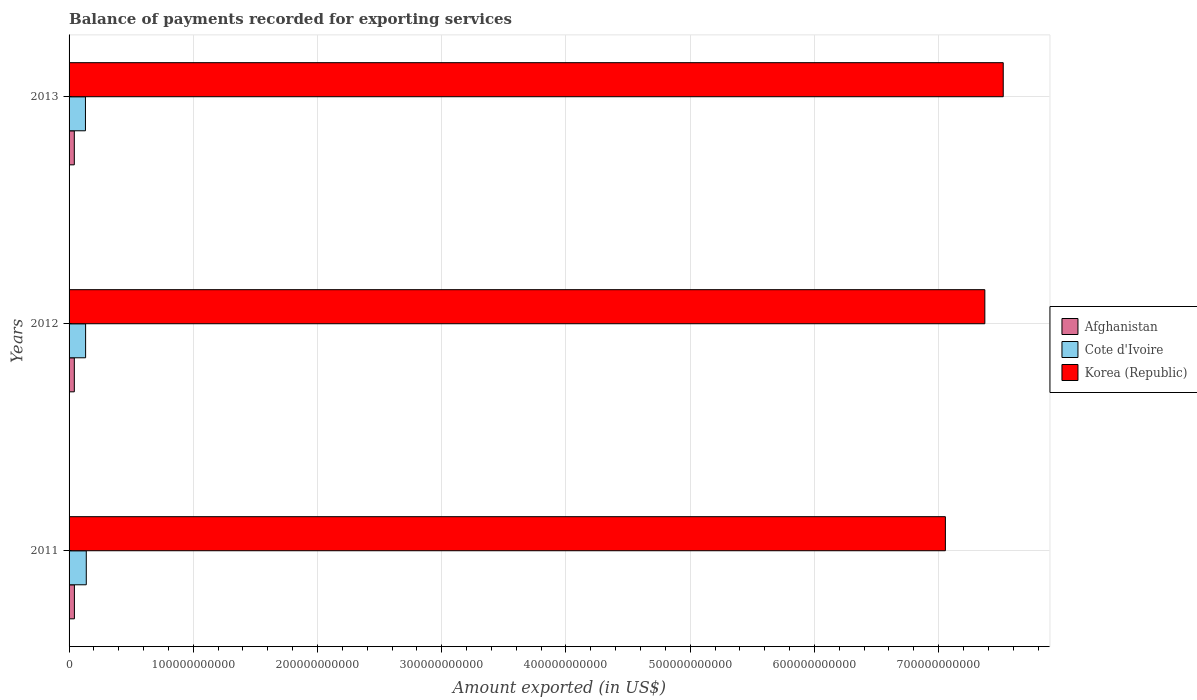Are the number of bars per tick equal to the number of legend labels?
Your answer should be very brief. Yes. Are the number of bars on each tick of the Y-axis equal?
Your answer should be compact. Yes. In how many cases, is the number of bars for a given year not equal to the number of legend labels?
Your response must be concise. 0. What is the amount exported in Cote d'Ivoire in 2013?
Ensure brevity in your answer.  1.32e+1. Across all years, what is the maximum amount exported in Afghanistan?
Your answer should be very brief. 4.30e+09. Across all years, what is the minimum amount exported in Afghanistan?
Provide a succinct answer. 4.22e+09. In which year was the amount exported in Afghanistan maximum?
Your answer should be very brief. 2011. What is the total amount exported in Cote d'Ivoire in the graph?
Your answer should be compact. 4.04e+1. What is the difference between the amount exported in Korea (Republic) in 2012 and that in 2013?
Ensure brevity in your answer.  -1.48e+1. What is the difference between the amount exported in Korea (Republic) in 2013 and the amount exported in Afghanistan in 2012?
Your answer should be compact. 7.48e+11. What is the average amount exported in Cote d'Ivoire per year?
Offer a terse response. 1.35e+1. In the year 2011, what is the difference between the amount exported in Afghanistan and amount exported in Korea (Republic)?
Your answer should be very brief. -7.01e+11. What is the ratio of the amount exported in Afghanistan in 2011 to that in 2012?
Make the answer very short. 1.01. Is the amount exported in Korea (Republic) in 2012 less than that in 2013?
Provide a short and direct response. Yes. Is the difference between the amount exported in Afghanistan in 2012 and 2013 greater than the difference between the amount exported in Korea (Republic) in 2012 and 2013?
Offer a terse response. Yes. What is the difference between the highest and the second highest amount exported in Korea (Republic)?
Make the answer very short. 1.48e+1. What is the difference between the highest and the lowest amount exported in Cote d'Ivoire?
Offer a very short reply. 6.68e+08. Is the sum of the amount exported in Korea (Republic) in 2011 and 2013 greater than the maximum amount exported in Cote d'Ivoire across all years?
Your answer should be compact. Yes. What does the 1st bar from the bottom in 2012 represents?
Your answer should be compact. Afghanistan. How many bars are there?
Give a very brief answer. 9. What is the difference between two consecutive major ticks on the X-axis?
Offer a terse response. 1.00e+11. Does the graph contain any zero values?
Make the answer very short. No. Does the graph contain grids?
Keep it short and to the point. Yes. How are the legend labels stacked?
Ensure brevity in your answer.  Vertical. What is the title of the graph?
Offer a very short reply. Balance of payments recorded for exporting services. What is the label or title of the X-axis?
Ensure brevity in your answer.  Amount exported (in US$). What is the label or title of the Y-axis?
Your response must be concise. Years. What is the Amount exported (in US$) of Afghanistan in 2011?
Your answer should be very brief. 4.30e+09. What is the Amount exported (in US$) in Cote d'Ivoire in 2011?
Provide a short and direct response. 1.39e+1. What is the Amount exported (in US$) of Korea (Republic) in 2011?
Provide a succinct answer. 7.05e+11. What is the Amount exported (in US$) of Afghanistan in 2012?
Offer a terse response. 4.24e+09. What is the Amount exported (in US$) in Cote d'Ivoire in 2012?
Your response must be concise. 1.33e+1. What is the Amount exported (in US$) of Korea (Republic) in 2012?
Give a very brief answer. 7.37e+11. What is the Amount exported (in US$) of Afghanistan in 2013?
Give a very brief answer. 4.22e+09. What is the Amount exported (in US$) of Cote d'Ivoire in 2013?
Your answer should be compact. 1.32e+1. What is the Amount exported (in US$) in Korea (Republic) in 2013?
Offer a very short reply. 7.52e+11. Across all years, what is the maximum Amount exported (in US$) of Afghanistan?
Your answer should be compact. 4.30e+09. Across all years, what is the maximum Amount exported (in US$) of Cote d'Ivoire?
Your answer should be very brief. 1.39e+1. Across all years, what is the maximum Amount exported (in US$) of Korea (Republic)?
Offer a very short reply. 7.52e+11. Across all years, what is the minimum Amount exported (in US$) of Afghanistan?
Your answer should be very brief. 4.22e+09. Across all years, what is the minimum Amount exported (in US$) of Cote d'Ivoire?
Your answer should be very brief. 1.32e+1. Across all years, what is the minimum Amount exported (in US$) of Korea (Republic)?
Offer a very short reply. 7.05e+11. What is the total Amount exported (in US$) in Afghanistan in the graph?
Provide a short and direct response. 1.28e+1. What is the total Amount exported (in US$) of Cote d'Ivoire in the graph?
Provide a succinct answer. 4.04e+1. What is the total Amount exported (in US$) of Korea (Republic) in the graph?
Give a very brief answer. 2.19e+12. What is the difference between the Amount exported (in US$) of Afghanistan in 2011 and that in 2012?
Give a very brief answer. 6.19e+07. What is the difference between the Amount exported (in US$) in Cote d'Ivoire in 2011 and that in 2012?
Keep it short and to the point. 5.43e+08. What is the difference between the Amount exported (in US$) in Korea (Republic) in 2011 and that in 2012?
Your answer should be very brief. -3.18e+1. What is the difference between the Amount exported (in US$) of Afghanistan in 2011 and that in 2013?
Provide a short and direct response. 7.85e+07. What is the difference between the Amount exported (in US$) of Cote d'Ivoire in 2011 and that in 2013?
Provide a short and direct response. 6.68e+08. What is the difference between the Amount exported (in US$) in Korea (Republic) in 2011 and that in 2013?
Ensure brevity in your answer.  -4.66e+1. What is the difference between the Amount exported (in US$) of Afghanistan in 2012 and that in 2013?
Provide a short and direct response. 1.66e+07. What is the difference between the Amount exported (in US$) of Cote d'Ivoire in 2012 and that in 2013?
Provide a short and direct response. 1.24e+08. What is the difference between the Amount exported (in US$) in Korea (Republic) in 2012 and that in 2013?
Your response must be concise. -1.48e+1. What is the difference between the Amount exported (in US$) of Afghanistan in 2011 and the Amount exported (in US$) of Cote d'Ivoire in 2012?
Provide a succinct answer. -9.02e+09. What is the difference between the Amount exported (in US$) of Afghanistan in 2011 and the Amount exported (in US$) of Korea (Republic) in 2012?
Offer a terse response. -7.33e+11. What is the difference between the Amount exported (in US$) in Cote d'Ivoire in 2011 and the Amount exported (in US$) in Korea (Republic) in 2012?
Provide a succinct answer. -7.23e+11. What is the difference between the Amount exported (in US$) of Afghanistan in 2011 and the Amount exported (in US$) of Cote d'Ivoire in 2013?
Give a very brief answer. -8.89e+09. What is the difference between the Amount exported (in US$) in Afghanistan in 2011 and the Amount exported (in US$) in Korea (Republic) in 2013?
Keep it short and to the point. -7.48e+11. What is the difference between the Amount exported (in US$) in Cote d'Ivoire in 2011 and the Amount exported (in US$) in Korea (Republic) in 2013?
Keep it short and to the point. -7.38e+11. What is the difference between the Amount exported (in US$) of Afghanistan in 2012 and the Amount exported (in US$) of Cote d'Ivoire in 2013?
Give a very brief answer. -8.95e+09. What is the difference between the Amount exported (in US$) in Afghanistan in 2012 and the Amount exported (in US$) in Korea (Republic) in 2013?
Your answer should be compact. -7.48e+11. What is the difference between the Amount exported (in US$) of Cote d'Ivoire in 2012 and the Amount exported (in US$) of Korea (Republic) in 2013?
Provide a succinct answer. -7.39e+11. What is the average Amount exported (in US$) in Afghanistan per year?
Your response must be concise. 4.25e+09. What is the average Amount exported (in US$) in Cote d'Ivoire per year?
Make the answer very short. 1.35e+1. What is the average Amount exported (in US$) of Korea (Republic) per year?
Make the answer very short. 7.32e+11. In the year 2011, what is the difference between the Amount exported (in US$) in Afghanistan and Amount exported (in US$) in Cote d'Ivoire?
Offer a very short reply. -9.56e+09. In the year 2011, what is the difference between the Amount exported (in US$) of Afghanistan and Amount exported (in US$) of Korea (Republic)?
Your answer should be compact. -7.01e+11. In the year 2011, what is the difference between the Amount exported (in US$) in Cote d'Ivoire and Amount exported (in US$) in Korea (Republic)?
Provide a short and direct response. -6.92e+11. In the year 2012, what is the difference between the Amount exported (in US$) of Afghanistan and Amount exported (in US$) of Cote d'Ivoire?
Give a very brief answer. -9.08e+09. In the year 2012, what is the difference between the Amount exported (in US$) in Afghanistan and Amount exported (in US$) in Korea (Republic)?
Offer a very short reply. -7.33e+11. In the year 2012, what is the difference between the Amount exported (in US$) in Cote d'Ivoire and Amount exported (in US$) in Korea (Republic)?
Your answer should be compact. -7.24e+11. In the year 2013, what is the difference between the Amount exported (in US$) in Afghanistan and Amount exported (in US$) in Cote d'Ivoire?
Provide a succinct answer. -8.97e+09. In the year 2013, what is the difference between the Amount exported (in US$) of Afghanistan and Amount exported (in US$) of Korea (Republic)?
Your answer should be very brief. -7.48e+11. In the year 2013, what is the difference between the Amount exported (in US$) in Cote d'Ivoire and Amount exported (in US$) in Korea (Republic)?
Provide a succinct answer. -7.39e+11. What is the ratio of the Amount exported (in US$) of Afghanistan in 2011 to that in 2012?
Provide a short and direct response. 1.01. What is the ratio of the Amount exported (in US$) of Cote d'Ivoire in 2011 to that in 2012?
Provide a short and direct response. 1.04. What is the ratio of the Amount exported (in US$) in Korea (Republic) in 2011 to that in 2012?
Provide a short and direct response. 0.96. What is the ratio of the Amount exported (in US$) in Afghanistan in 2011 to that in 2013?
Your answer should be compact. 1.02. What is the ratio of the Amount exported (in US$) in Cote d'Ivoire in 2011 to that in 2013?
Your answer should be compact. 1.05. What is the ratio of the Amount exported (in US$) in Korea (Republic) in 2011 to that in 2013?
Your answer should be compact. 0.94. What is the ratio of the Amount exported (in US$) in Afghanistan in 2012 to that in 2013?
Your response must be concise. 1. What is the ratio of the Amount exported (in US$) of Cote d'Ivoire in 2012 to that in 2013?
Your answer should be very brief. 1.01. What is the ratio of the Amount exported (in US$) of Korea (Republic) in 2012 to that in 2013?
Make the answer very short. 0.98. What is the difference between the highest and the second highest Amount exported (in US$) in Afghanistan?
Ensure brevity in your answer.  6.19e+07. What is the difference between the highest and the second highest Amount exported (in US$) in Cote d'Ivoire?
Your response must be concise. 5.43e+08. What is the difference between the highest and the second highest Amount exported (in US$) in Korea (Republic)?
Make the answer very short. 1.48e+1. What is the difference between the highest and the lowest Amount exported (in US$) of Afghanistan?
Keep it short and to the point. 7.85e+07. What is the difference between the highest and the lowest Amount exported (in US$) of Cote d'Ivoire?
Provide a succinct answer. 6.68e+08. What is the difference between the highest and the lowest Amount exported (in US$) of Korea (Republic)?
Ensure brevity in your answer.  4.66e+1. 